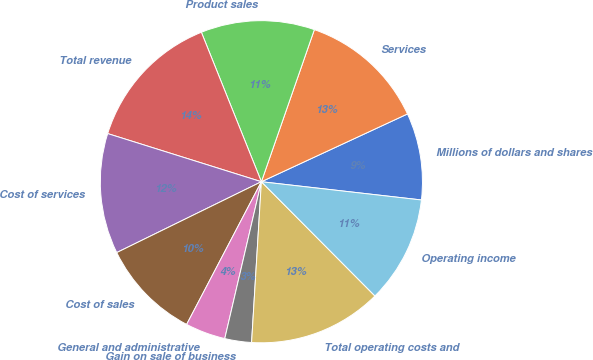Convert chart. <chart><loc_0><loc_0><loc_500><loc_500><pie_chart><fcel>Millions of dollars and shares<fcel>Services<fcel>Product sales<fcel>Total revenue<fcel>Cost of services<fcel>Cost of sales<fcel>General and administrative<fcel>Gain on sale of business<fcel>Total operating costs and<fcel>Operating income<nl><fcel>8.72%<fcel>12.75%<fcel>11.41%<fcel>14.09%<fcel>12.08%<fcel>10.07%<fcel>4.03%<fcel>2.68%<fcel>13.42%<fcel>10.74%<nl></chart> 